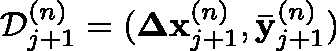<formula> <loc_0><loc_0><loc_500><loc_500>\mathcal { D } _ { j + 1 } ^ { ( n ) } = ( \Delta x _ { j + 1 } ^ { ( n ) } , \bar { y } _ { j + 1 } ^ { ( n ) } )</formula> 